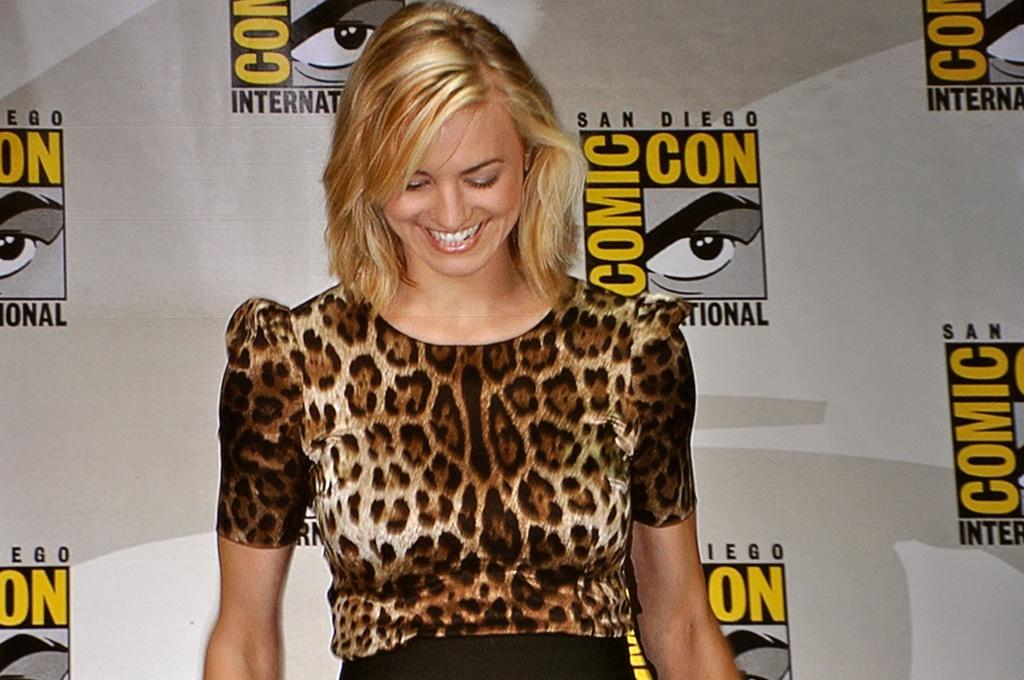Who is present in the image? There is a woman in the image. What is the woman's facial expression? The woman is smiling. What can be seen in the background of the image? There is a banner in the background of the image. What type of sand can be seen in the woman's meal in the image? There is no meal or sand present in the image; it only features a woman and a banner in the background. 